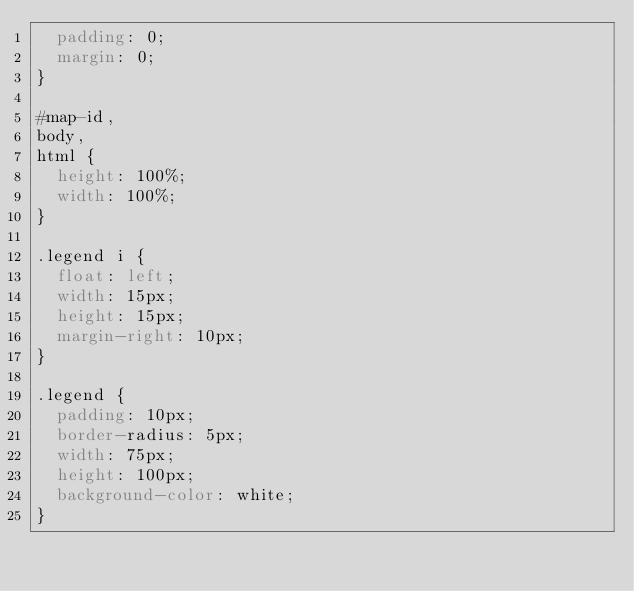Convert code to text. <code><loc_0><loc_0><loc_500><loc_500><_CSS_>  padding: 0;
  margin: 0;
}

#map-id,
body,
html {
  height: 100%;
  width: 100%;
}

.legend i {
  float: left; 
  width: 15px; 
  height: 15px; 
  margin-right: 10px; 
}

.legend {
  padding: 10px; 
  border-radius: 5px;
  width: 75px;
  height: 100px;
  background-color: white;
}</code> 